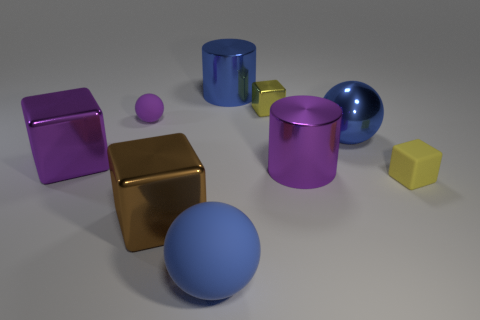Subtract all small yellow matte cubes. How many cubes are left? 3 Add 1 purple things. How many objects exist? 10 Subtract 1 spheres. How many spheres are left? 2 Subtract all purple cubes. How many cubes are left? 3 Subtract 1 purple balls. How many objects are left? 8 Subtract all balls. How many objects are left? 6 Subtract all yellow balls. Subtract all red cylinders. How many balls are left? 3 Subtract all large metallic blocks. Subtract all small purple spheres. How many objects are left? 6 Add 9 blue cylinders. How many blue cylinders are left? 10 Add 2 small cyan matte things. How many small cyan matte things exist? 2 